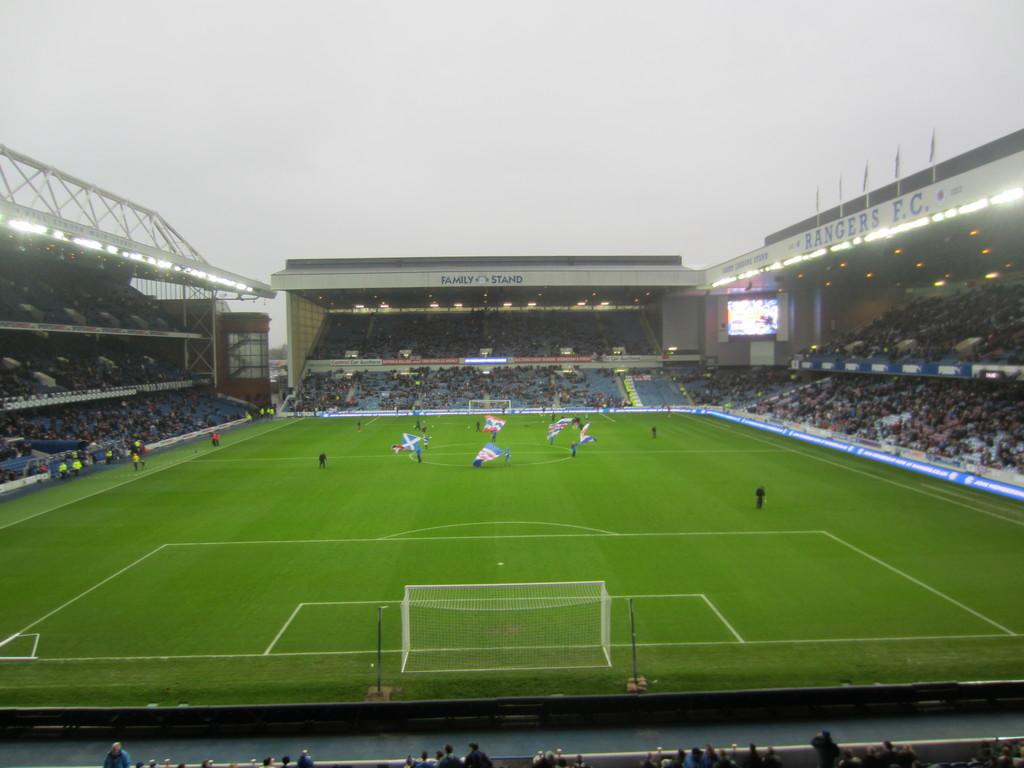Provide a one-sentence caption for the provided image. One side of an outdoor stadium is labeled, "RANGERS F.C.". 